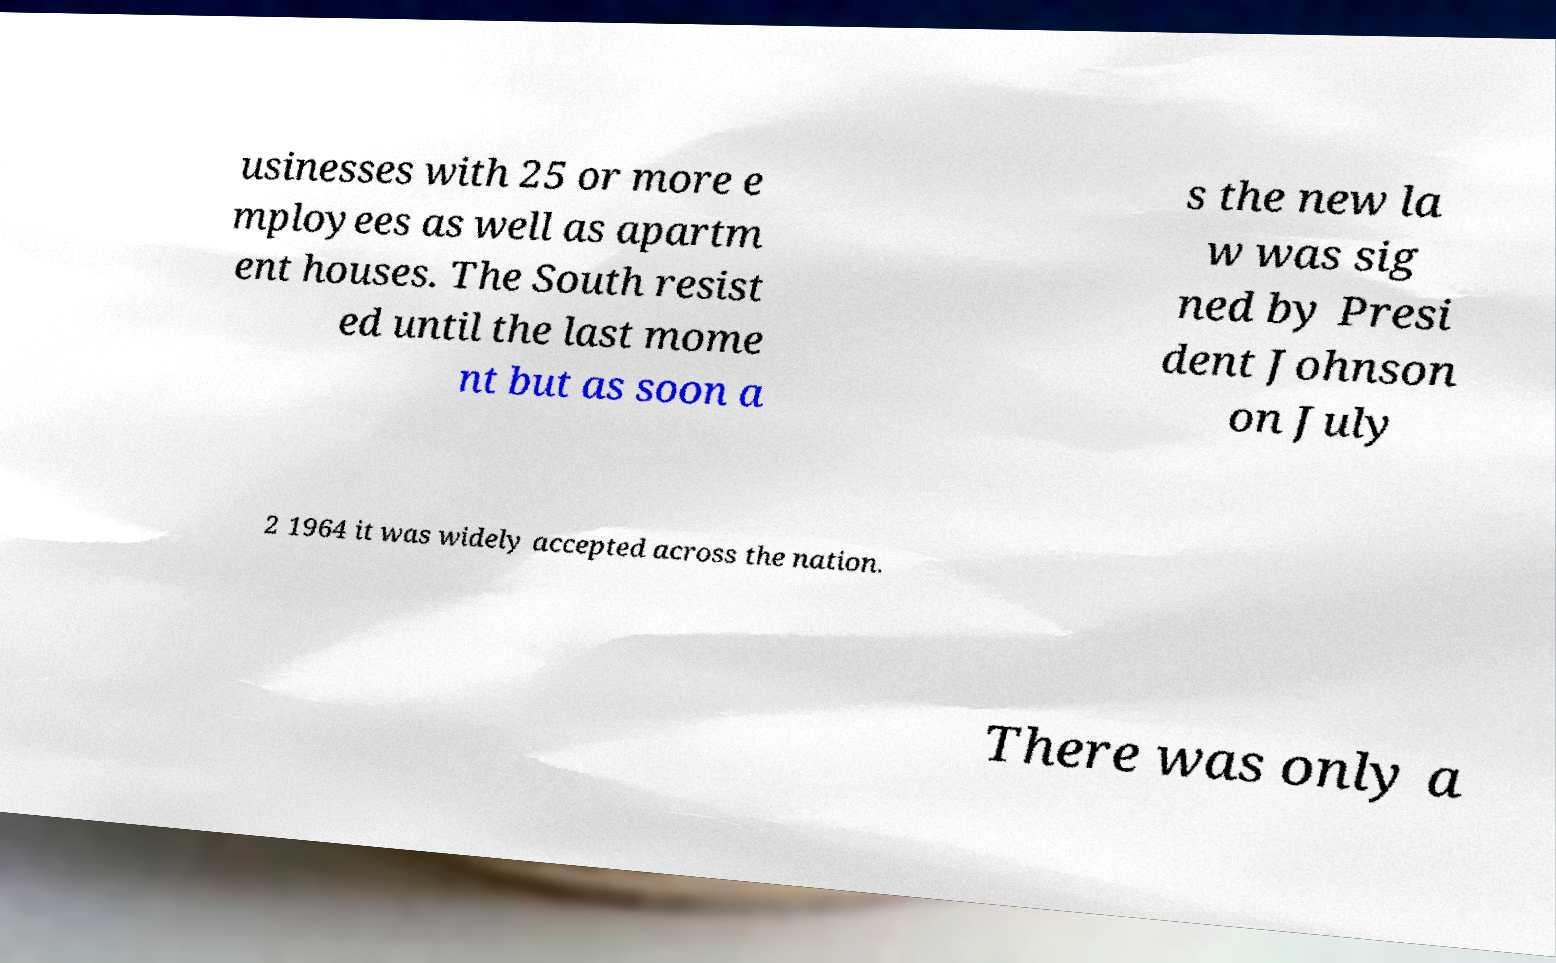Can you read and provide the text displayed in the image?This photo seems to have some interesting text. Can you extract and type it out for me? usinesses with 25 or more e mployees as well as apartm ent houses. The South resist ed until the last mome nt but as soon a s the new la w was sig ned by Presi dent Johnson on July 2 1964 it was widely accepted across the nation. There was only a 